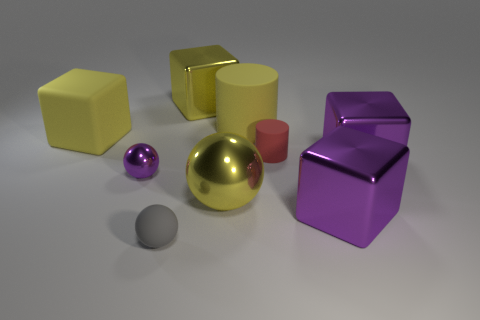There is a small thing behind the purple metal thing that is on the left side of the shiny block behind the small matte cylinder; what color is it?
Offer a terse response. Red. How many large things are either gray matte cubes or rubber cubes?
Offer a very short reply. 1. Are there the same number of gray rubber things behind the small shiny sphere and small metal objects?
Provide a short and direct response. No. There is a large yellow rubber cylinder; are there any large metal cubes on the left side of it?
Keep it short and to the point. Yes. What number of matte objects are cylinders or small things?
Offer a terse response. 3. What number of objects are on the left side of the tiny red cylinder?
Keep it short and to the point. 6. Is there a purple sphere that has the same size as the yellow metallic block?
Provide a succinct answer. No. Are there any small metallic spheres of the same color as the large rubber cube?
Keep it short and to the point. No. Is there anything else that has the same size as the matte sphere?
Offer a very short reply. Yes. How many matte cylinders are the same color as the big rubber block?
Make the answer very short. 1. 